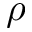<formula> <loc_0><loc_0><loc_500><loc_500>\rho</formula> 